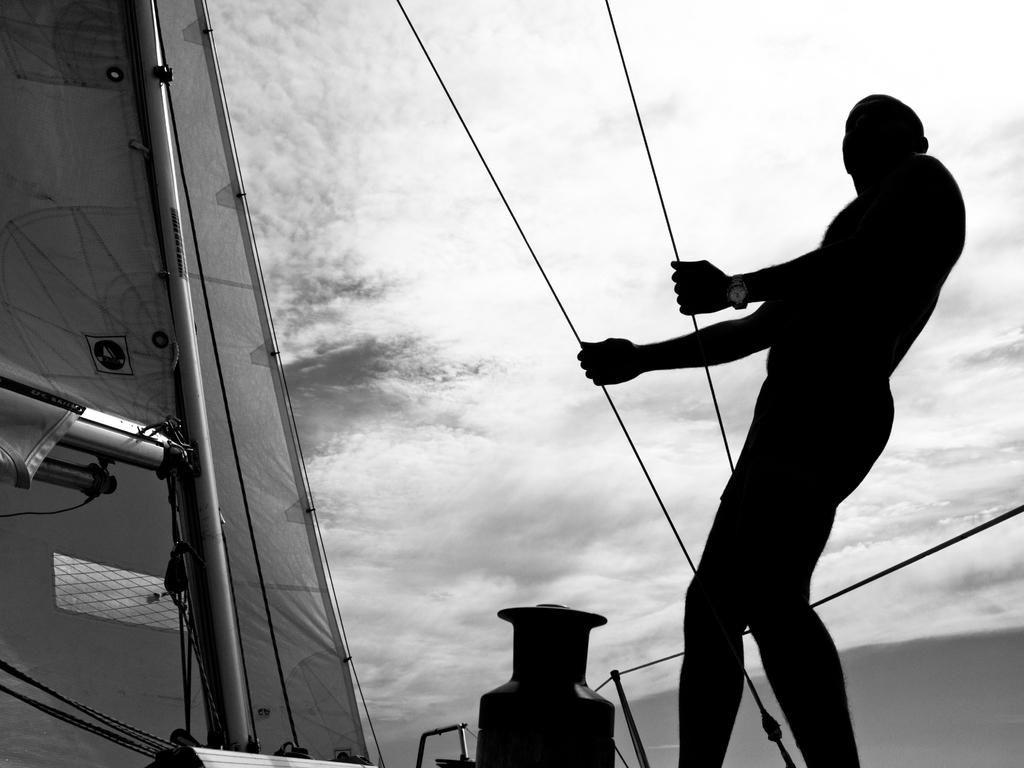What is the person in the image doing? The person is standing on a boat and holding wires. What else can be seen on the boat? There is an object on the boat. What is visible in the background of the image? The sky is visible in the background of the image. Can you describe the sky in the image? The sky has clouds in it. What type of glove is the person wearing in the image? There is no glove visible in the image; the person is holding wires. How does the person's anger affect the boat in the image? There is no indication of anger in the image, and it does not affect the boat. 